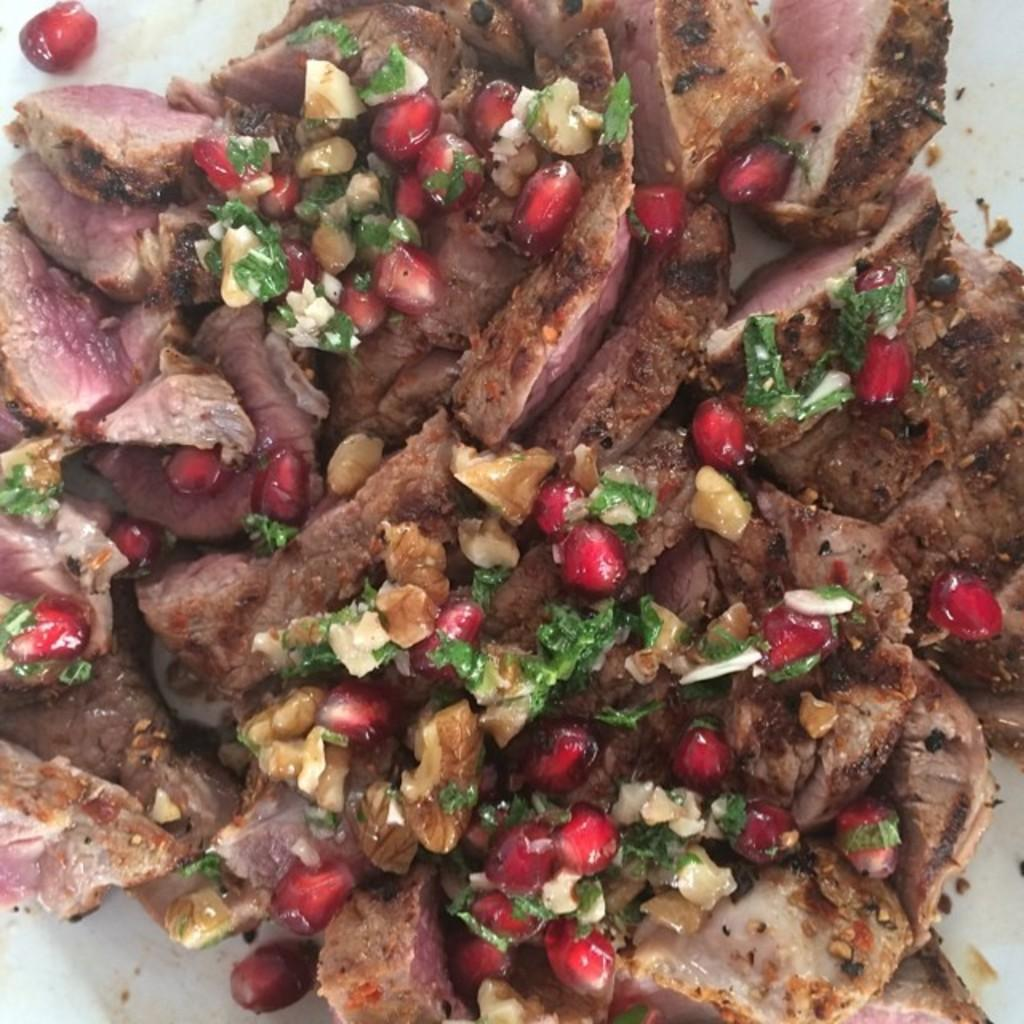What type of food is present in the image? The food in the image contains meat and pomegranate. How is the food arranged or presented? The food is in a plate. Can you see any squirrels eating the food in the image? There are no squirrels present in the image. What type of boats can be seen in the image? There are no boats present in the image. 